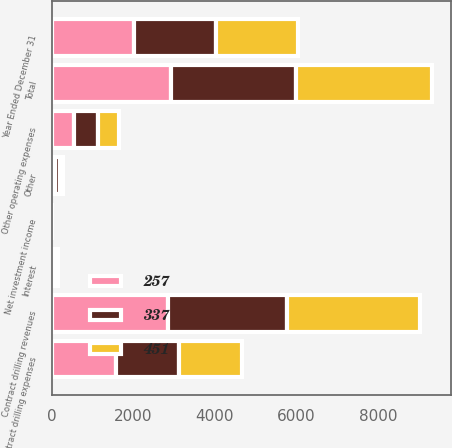Convert chart to OTSL. <chart><loc_0><loc_0><loc_500><loc_500><stacked_bar_chart><ecel><fcel>Year Ended December 31<fcel>Contract drilling revenues<fcel>Net investment income<fcel>Other<fcel>Total<fcel>Contract drilling expenses<fcel>Other operating expenses<fcel>Interest<nl><fcel>257<fcel>2013<fcel>2844<fcel>1<fcel>81<fcel>2926<fcel>1573<fcel>554<fcel>25<nl><fcel>337<fcel>2012<fcel>2936<fcel>5<fcel>131<fcel>3072<fcel>1537<fcel>572<fcel>46<nl><fcel>451<fcel>2011<fcel>3254<fcel>7<fcel>73<fcel>3335<fcel>1549<fcel>535<fcel>73<nl></chart> 